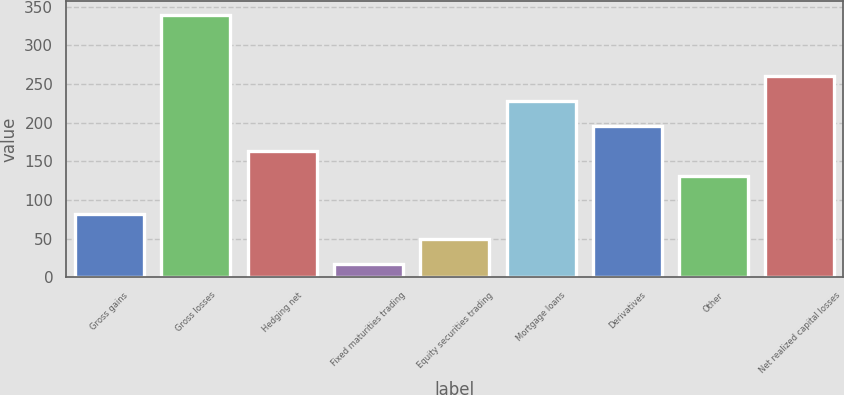<chart> <loc_0><loc_0><loc_500><loc_500><bar_chart><fcel>Gross gains<fcel>Gross losses<fcel>Hedging net<fcel>Fixed maturities trading<fcel>Equity securities trading<fcel>Mortgage loans<fcel>Derivatives<fcel>Other<fcel>Net realized capital losses<nl><fcel>81.98<fcel>339.9<fcel>163.84<fcel>17.5<fcel>49.74<fcel>228.32<fcel>196.08<fcel>131.6<fcel>260.56<nl></chart> 